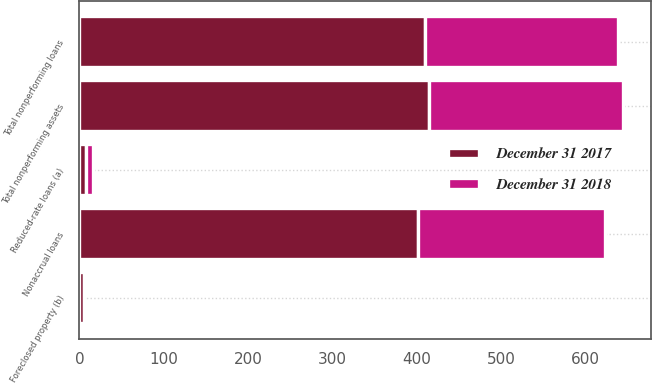Convert chart to OTSL. <chart><loc_0><loc_0><loc_500><loc_500><stacked_bar_chart><ecel><fcel>Nonaccrual loans<fcel>Reduced-rate loans (a)<fcel>Total nonperforming loans<fcel>Foreclosed property (b)<fcel>Total nonperforming assets<nl><fcel>December 31 2018<fcel>221<fcel>8<fcel>229<fcel>1<fcel>230<nl><fcel>December 31 2017<fcel>402<fcel>8<fcel>410<fcel>5<fcel>415<nl></chart> 